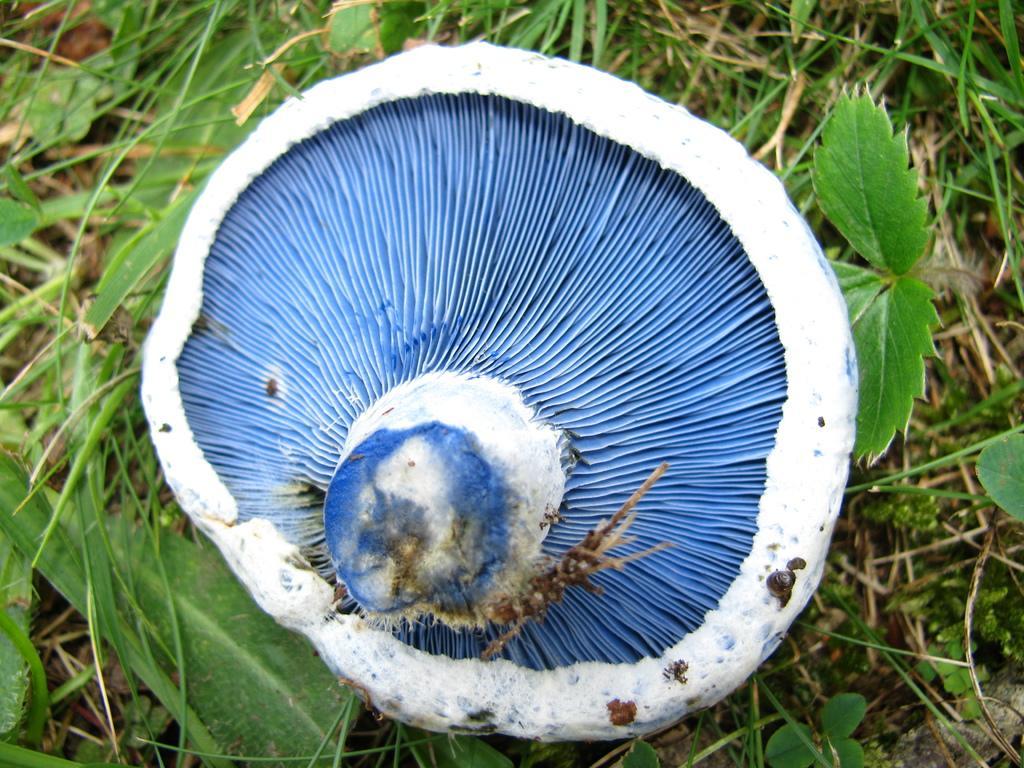Please provide a concise description of this image. Here we can see a mushroom. There are leaves and grass. 